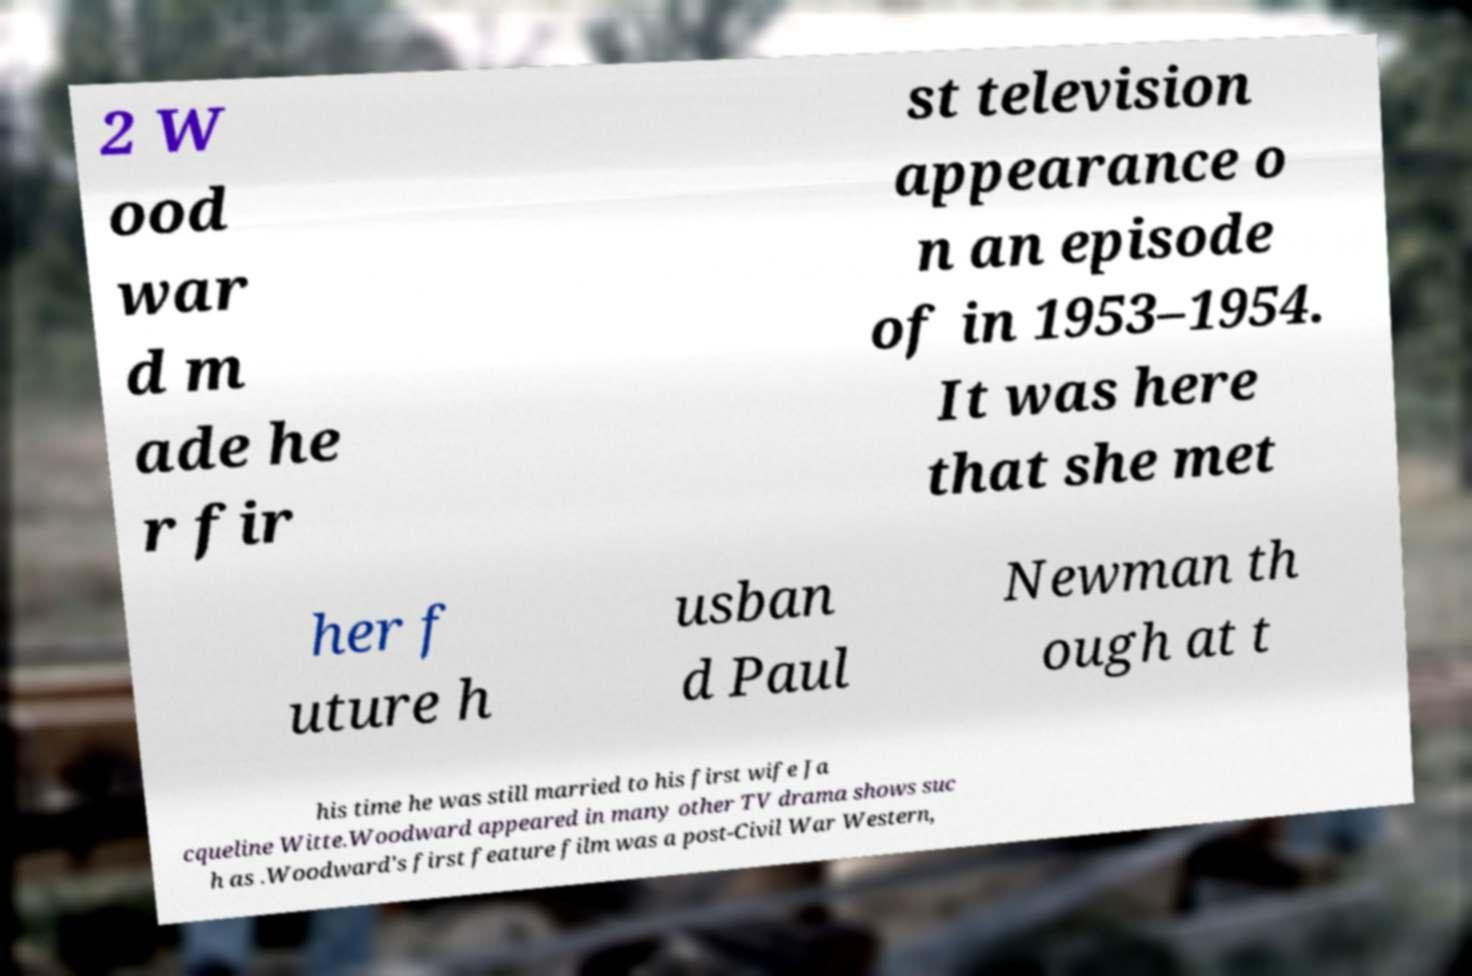Could you assist in decoding the text presented in this image and type it out clearly? 2 W ood war d m ade he r fir st television appearance o n an episode of in 1953–1954. It was here that she met her f uture h usban d Paul Newman th ough at t his time he was still married to his first wife Ja cqueline Witte.Woodward appeared in many other TV drama shows suc h as .Woodward's first feature film was a post-Civil War Western, 